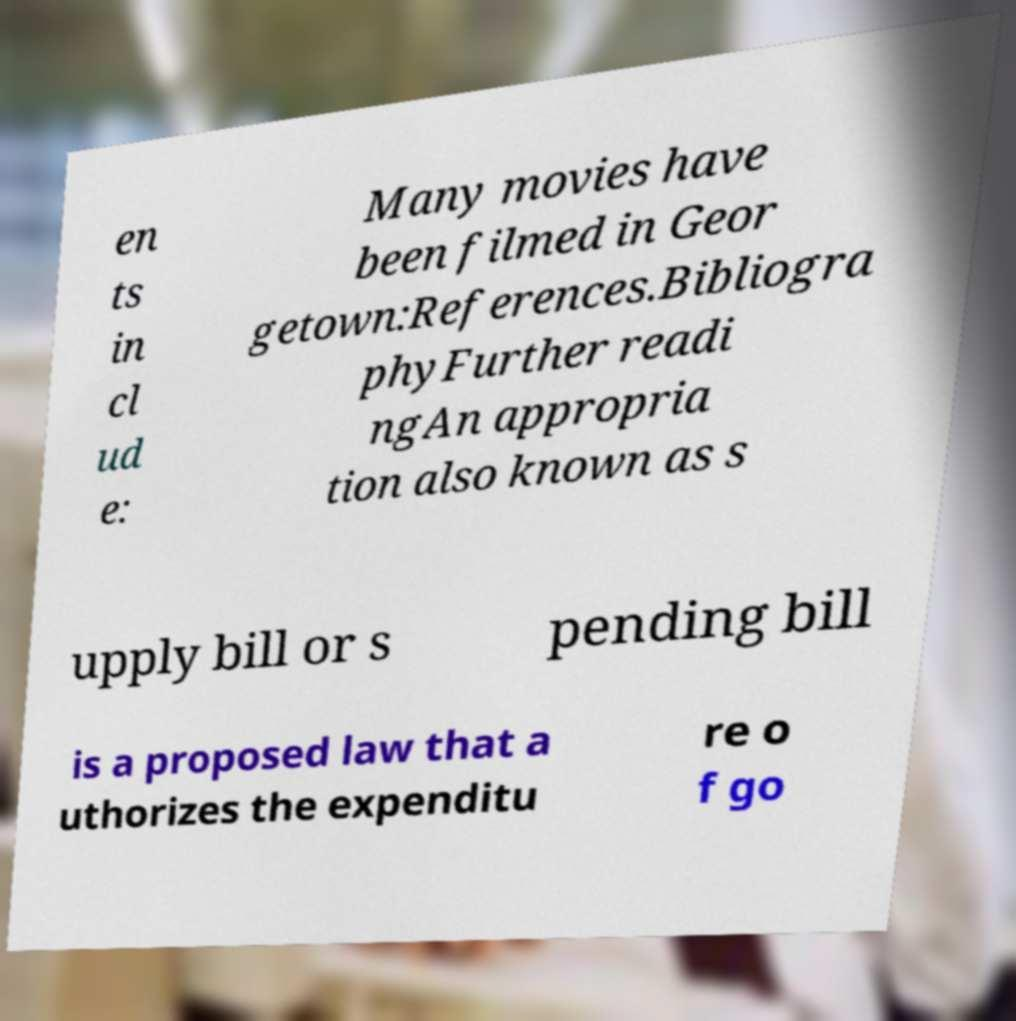Can you accurately transcribe the text from the provided image for me? en ts in cl ud e: Many movies have been filmed in Geor getown:References.Bibliogra phyFurther readi ngAn appropria tion also known as s upply bill or s pending bill is a proposed law that a uthorizes the expenditu re o f go 